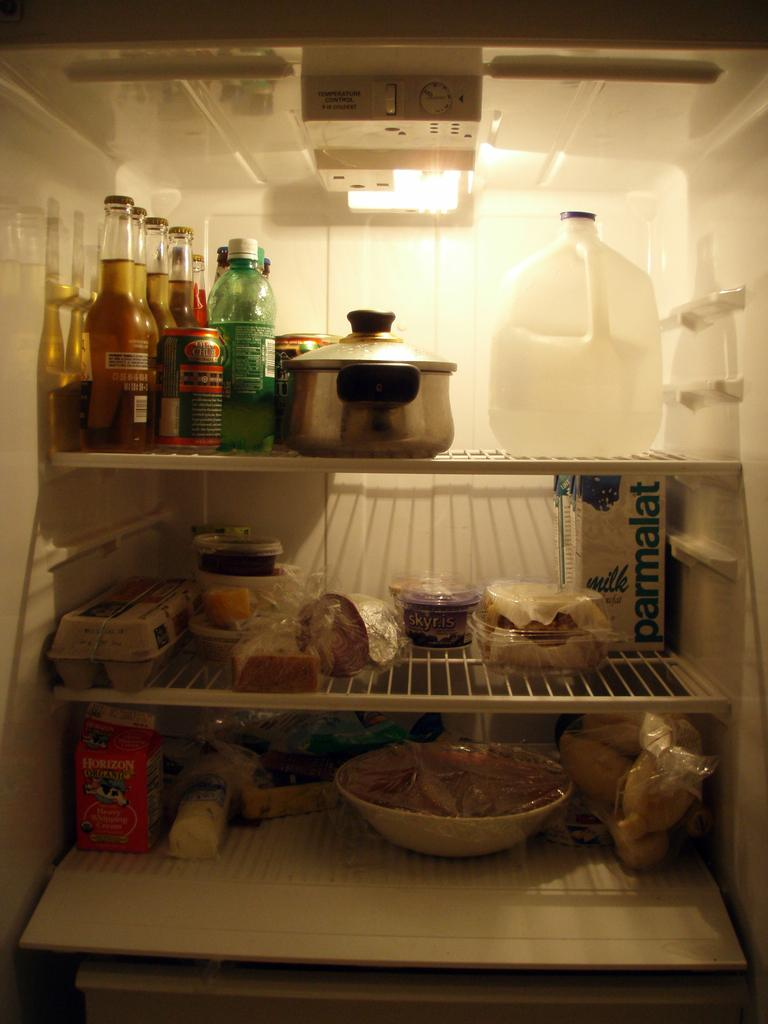<image>
Give a short and clear explanation of the subsequent image. Inside a fridge with many itmes in it and parmalat milk on the second shelf. 